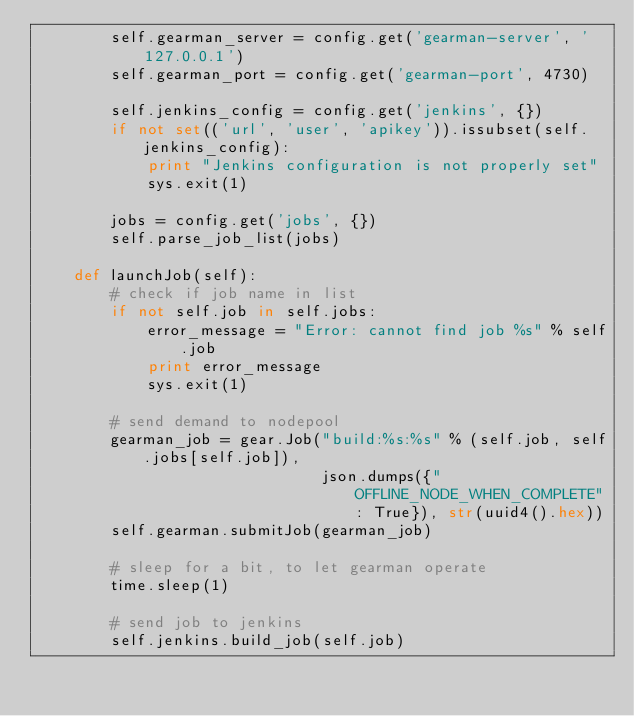<code> <loc_0><loc_0><loc_500><loc_500><_Python_>        self.gearman_server = config.get('gearman-server', '127.0.0.1')
        self.gearman_port = config.get('gearman-port', 4730)

        self.jenkins_config = config.get('jenkins', {})
        if not set(('url', 'user', 'apikey')).issubset(self.jenkins_config):
            print "Jenkins configuration is not properly set"
            sys.exit(1)

        jobs = config.get('jobs', {})
        self.parse_job_list(jobs)

    def launchJob(self):
        # check if job name in list
        if not self.job in self.jobs:
            error_message = "Error: cannot find job %s" % self.job
            print error_message
            sys.exit(1)

        # send demand to nodepool
        gearman_job = gear.Job("build:%s:%s" % (self.job, self.jobs[self.job]),
                               json.dumps({"OFFLINE_NODE_WHEN_COMPLETE": True}), str(uuid4().hex))
        self.gearman.submitJob(gearman_job)

        # sleep for a bit, to let gearman operate
        time.sleep(1)

        # send job to jenkins
        self.jenkins.build_job(self.job)
</code> 